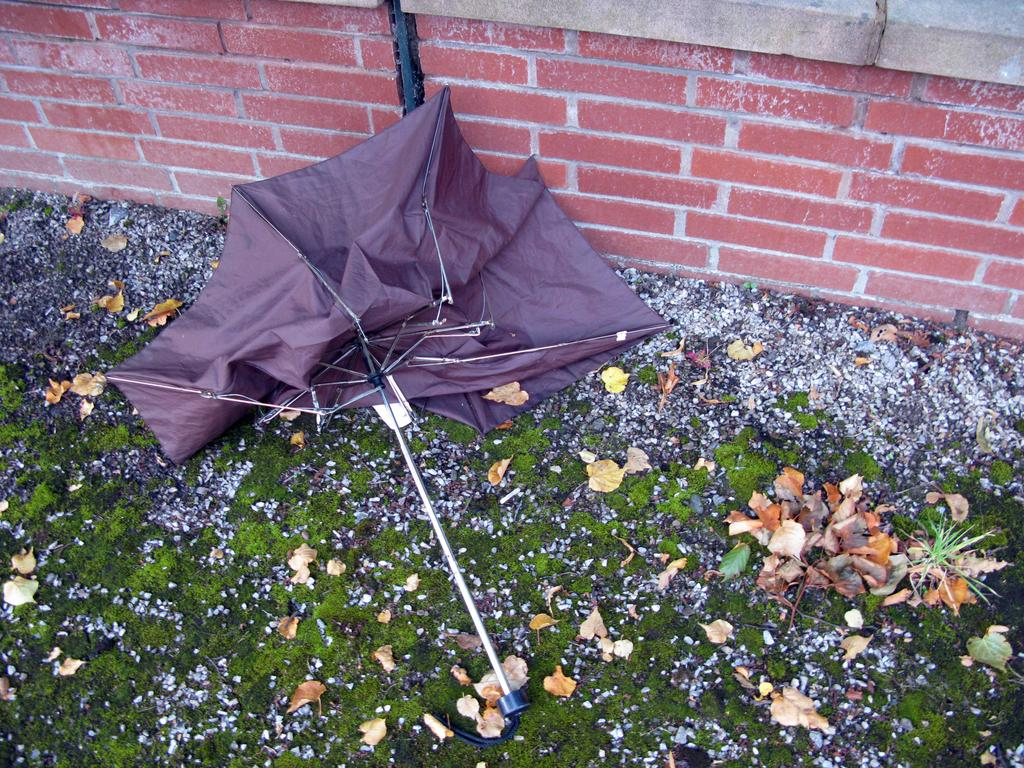What type of ground cover can be seen in the image? There is green grass on the ground in the image. What else is present on the ground in the image? There are dry leaves on the ground in the image. What object is visible in the image that might be used for protection from the sun or rain? There is an umbrella in the image. What type of structure is present in the image? There is a wall in the image. How many chickens are sitting on the drawer in the image? There is no drawer or chickens present in the image. What type of amphibian can be seen hopping near the wall in the image? There is no amphibian, such as a toad, present in the image. 